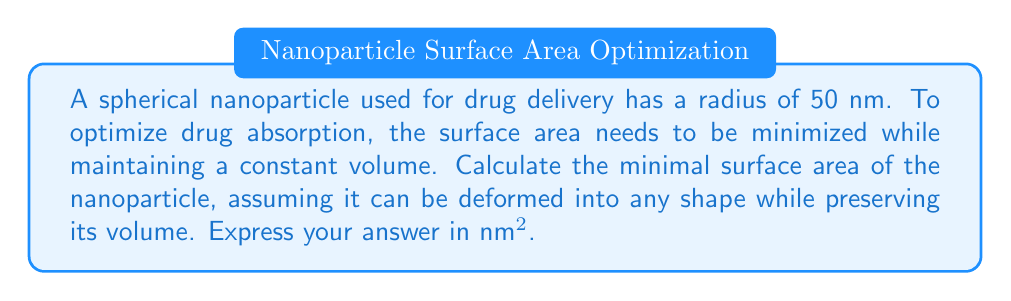Give your solution to this math problem. To solve this problem, we'll use the isoperimetric inequality in three dimensions, which states that among all closed surfaces with a given volume, the sphere has the smallest surface area.

Step 1: Calculate the volume of the original spherical nanoparticle.
Volume of a sphere: $V = \frac{4}{3}\pi r^3$
$V = \frac{4}{3}\pi (50\text{ nm})^3 = \frac{4}{3}\pi \cdot 125000\text{ nm}^3$

Step 2: Since the volume must remain constant, any shape with this volume will have a surface area greater than or equal to that of a sphere with the same volume.

Step 3: Calculate the radius of the sphere with the minimal surface area.
$r = \sqrt[3]{\frac{3V}{4\pi}} = \sqrt[3]{\frac{3 \cdot \frac{4}{3}\pi \cdot 125000\text{ nm}^3}{4\pi}} = 50\text{ nm}$

Step 4: Calculate the surface area of this sphere.
Surface area of a sphere: $A = 4\pi r^2$
$A = 4\pi (50\text{ nm})^2 = 4\pi \cdot 2500\text{ nm}^2 = 10000\pi\text{ nm}^2$

Therefore, the minimal surface area of the nanoparticle, regardless of its shape, is $10000\pi\text{ nm}^2$.
Answer: $10000\pi\text{ nm}^2$ 